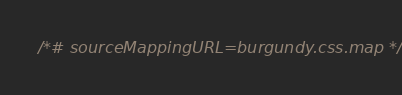<code> <loc_0><loc_0><loc_500><loc_500><_CSS_>/*# sourceMappingURL=burgundy.css.map */</code> 